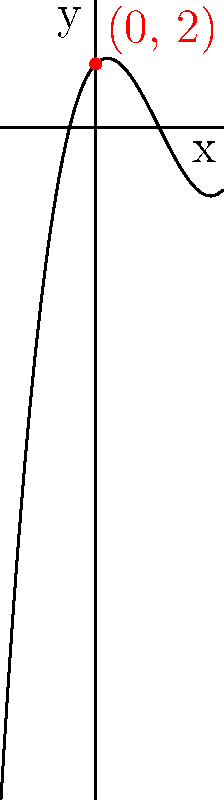In the context of content optimization using NLP, consider the polynomial function represented by the graph above. What is the y-intercept of this function, and how might this concept relate to analyzing the initial impact of your content strategy? To find the y-intercept of a polynomial function from its graph, we need to follow these steps:

1. Recall that the y-intercept is the point where the graph crosses the y-axis.
2. The y-axis is the vertical line where $x = 0$.
3. Locate the point on the graph where it intersects the y-axis.
4. Read the y-coordinate of this point.

In this graph:
- We can see a red dot labeled $(0, 2)$ where the curve intersects the y-axis.
- This point represents the y-intercept.

Therefore, the y-intercept of this polynomial function is 2.

Relating this to content optimization and NLP:
- The y-intercept can be metaphorically understood as the "baseline" or initial impact of your content strategy.
- In NLP terms, it could represent the initial sentiment score or engagement level of your content before any optimization efforts.
- Just as the y-intercept is where the function "starts" on the y-axis, your initial content strategy is the starting point from which you'll measure improvements.
- Understanding this baseline (y-intercept) is crucial for measuring the effectiveness of your NLP-driven optimizations over time.
Answer: 2 